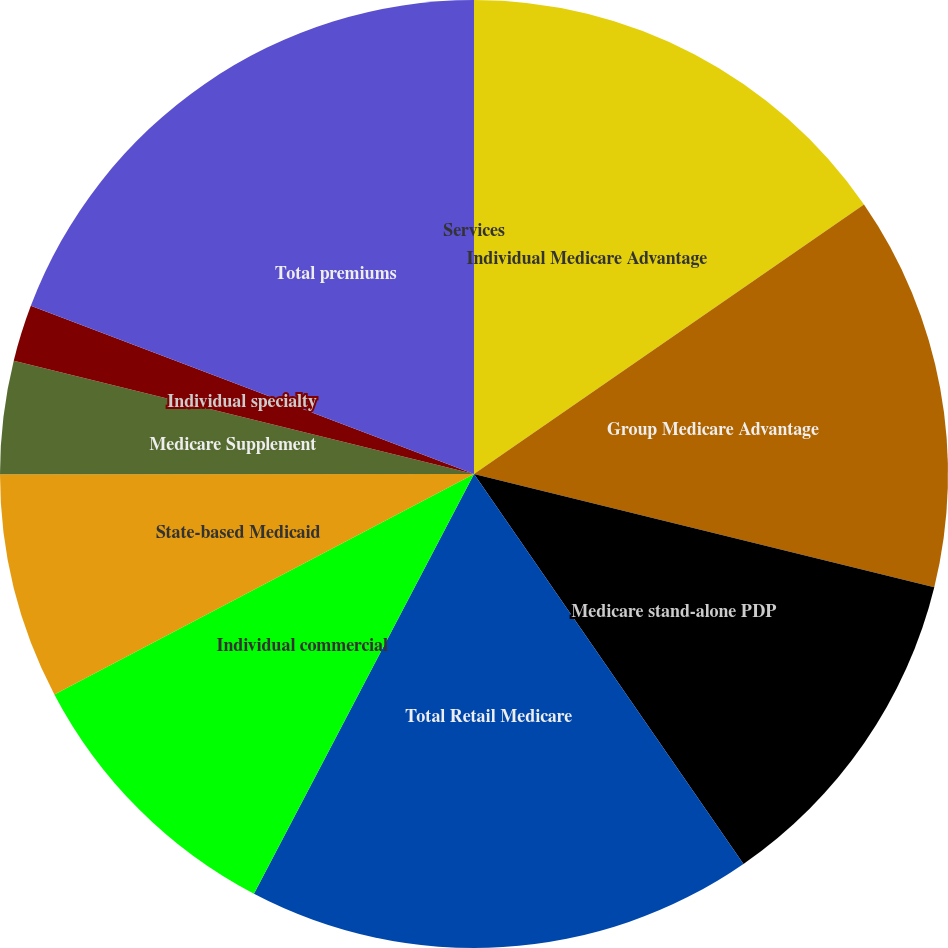<chart> <loc_0><loc_0><loc_500><loc_500><pie_chart><fcel>Individual Medicare Advantage<fcel>Group Medicare Advantage<fcel>Medicare stand-alone PDP<fcel>Total Retail Medicare<fcel>Individual commercial<fcel>State-based Medicaid<fcel>Medicare Supplement<fcel>Individual specialty<fcel>Total premiums<fcel>Services<nl><fcel>15.38%<fcel>13.46%<fcel>11.54%<fcel>17.31%<fcel>9.62%<fcel>7.69%<fcel>3.85%<fcel>1.93%<fcel>19.23%<fcel>0.0%<nl></chart> 